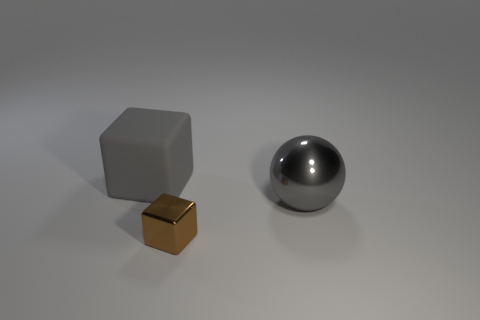Is there anything else that is the same material as the large gray block?
Your answer should be compact. No. What is the shape of the big gray object in front of the big thing behind the shiny thing behind the brown metal thing?
Provide a short and direct response. Sphere. How many other big gray blocks are the same material as the big block?
Provide a succinct answer. 0. How many big spheres are on the right side of the tiny block that is to the right of the large rubber object?
Your answer should be very brief. 1. What number of red rubber things are there?
Offer a very short reply. 0. Are the tiny cube and the gray thing left of the large shiny ball made of the same material?
Offer a terse response. No. There is a block that is to the right of the big matte thing; is its color the same as the matte object?
Keep it short and to the point. No. The thing that is on the right side of the matte object and left of the large metallic thing is made of what material?
Make the answer very short. Metal. What size is the matte object?
Offer a very short reply. Large. Is the color of the big metal sphere the same as the cube in front of the large gray matte object?
Provide a succinct answer. No. 